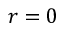<formula> <loc_0><loc_0><loc_500><loc_500>r = 0</formula> 